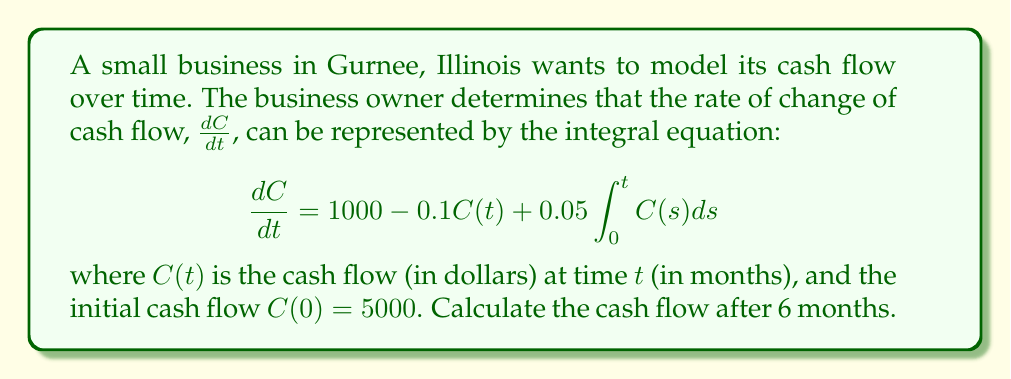Help me with this question. To solve this integral equation, we'll follow these steps:

1) First, we need to convert the integral equation into a differential equation. Let's define:

   $$y(t) = \int_0^t C(s)ds$$

2) Then, $\frac{dy}{dt} = C(t)$ and $y(0) = 0$

3) Our original equation becomes:

   $$\frac{d^2y}{dt^2} = 1000 - 0.1\frac{dy}{dt} + 0.05y$$

4) This is a second-order linear differential equation with constant coefficients. The characteristic equation is:

   $$r^2 + 0.1r - 0.05 = 0$$

5) Solving this, we get $r_1 \approx 0.1866$ and $r_2 \approx -0.2866$

6) The general solution for $y(t)$ is:

   $$y(t) = A e^{0.1866t} + B e^{-0.2866t} + 20000$$

7) To find $C(t)$, we differentiate $y(t)$:

   $$C(t) = \frac{dy}{dt} = 0.1866A e^{0.1866t} - 0.2866B e^{-0.2866t}$$

8) Using the initial conditions $C(0) = 5000$ and $y(0) = 0$, we can solve for $A$ and $B$:

   $$A \approx 26795.58, B \approx -6795.58$$

9) Therefore, the cash flow function is:

   $$C(t) = 5000.81 e^{0.1866t} + 1948.01 e^{-0.2866t}$$

10) To find the cash flow after 6 months, we substitute $t = 6$:

    $$C(6) = 5000.81 e^{0.1866(6)} + 1948.01 e^{-0.2866(6)} \approx 7889.37$$
Answer: $7889.37 